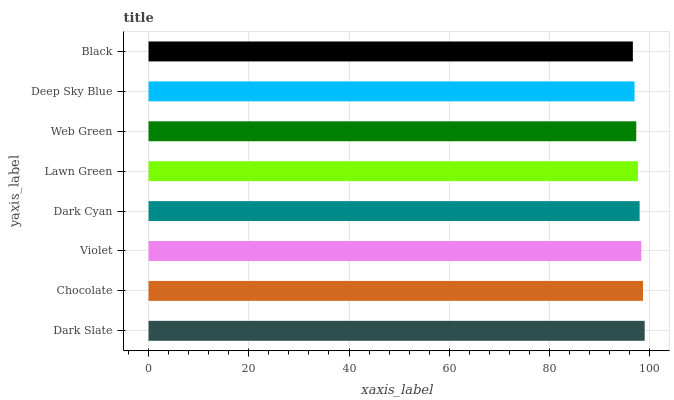Is Black the minimum?
Answer yes or no. Yes. Is Dark Slate the maximum?
Answer yes or no. Yes. Is Chocolate the minimum?
Answer yes or no. No. Is Chocolate the maximum?
Answer yes or no. No. Is Dark Slate greater than Chocolate?
Answer yes or no. Yes. Is Chocolate less than Dark Slate?
Answer yes or no. Yes. Is Chocolate greater than Dark Slate?
Answer yes or no. No. Is Dark Slate less than Chocolate?
Answer yes or no. No. Is Dark Cyan the high median?
Answer yes or no. Yes. Is Lawn Green the low median?
Answer yes or no. Yes. Is Dark Slate the high median?
Answer yes or no. No. Is Deep Sky Blue the low median?
Answer yes or no. No. 